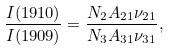<formula> <loc_0><loc_0><loc_500><loc_500>\frac { I ( 1 9 1 0 ) } { I ( 1 9 0 9 ) } = \frac { N _ { 2 } A _ { 2 1 } \nu _ { 2 1 } } { N _ { 3 } A _ { 3 1 } \nu _ { 3 1 } } ,</formula> 